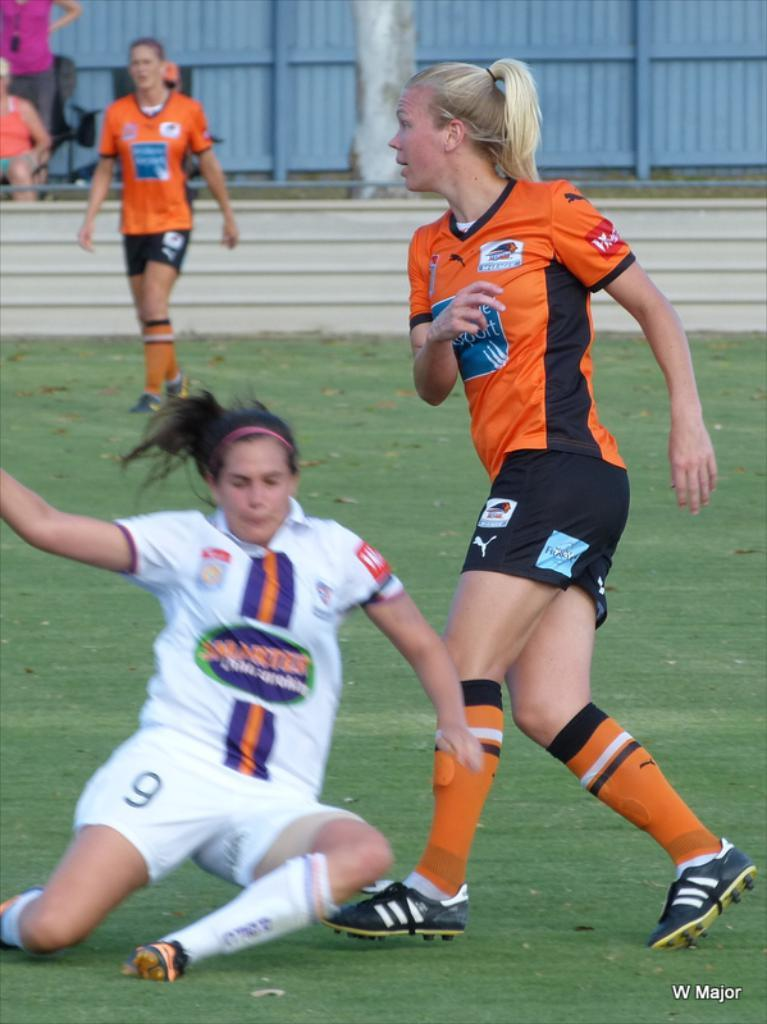<image>
Write a terse but informative summary of the picture. Three women are playing soccer with a W Major on the bottom right side of the photo. 